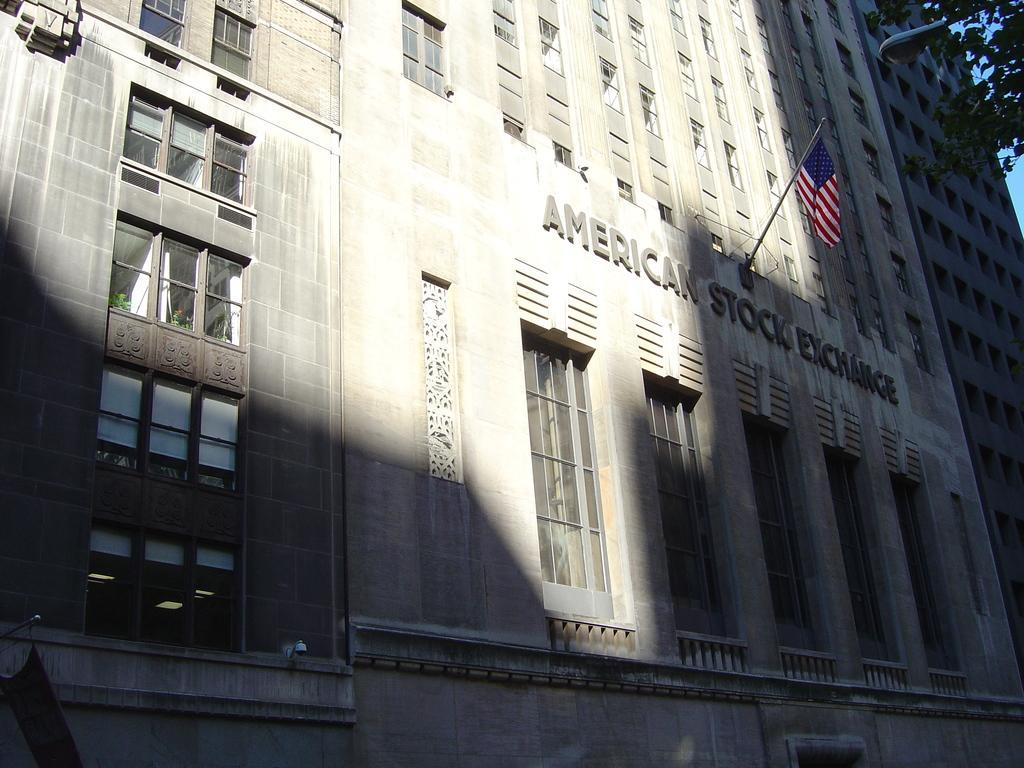In one or two sentences, can you explain what this image depicts? In this image we can see a building with group of windows and some text and a pole containing a flag on it. In the background, we can see trees and sky. 